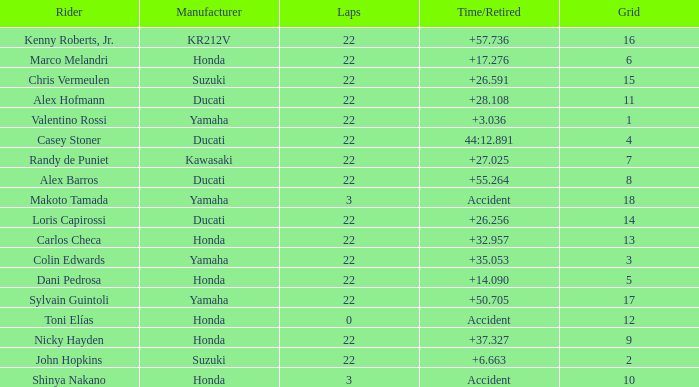What is the average grid for the competitiors who had laps smaller than 3? 12.0. 